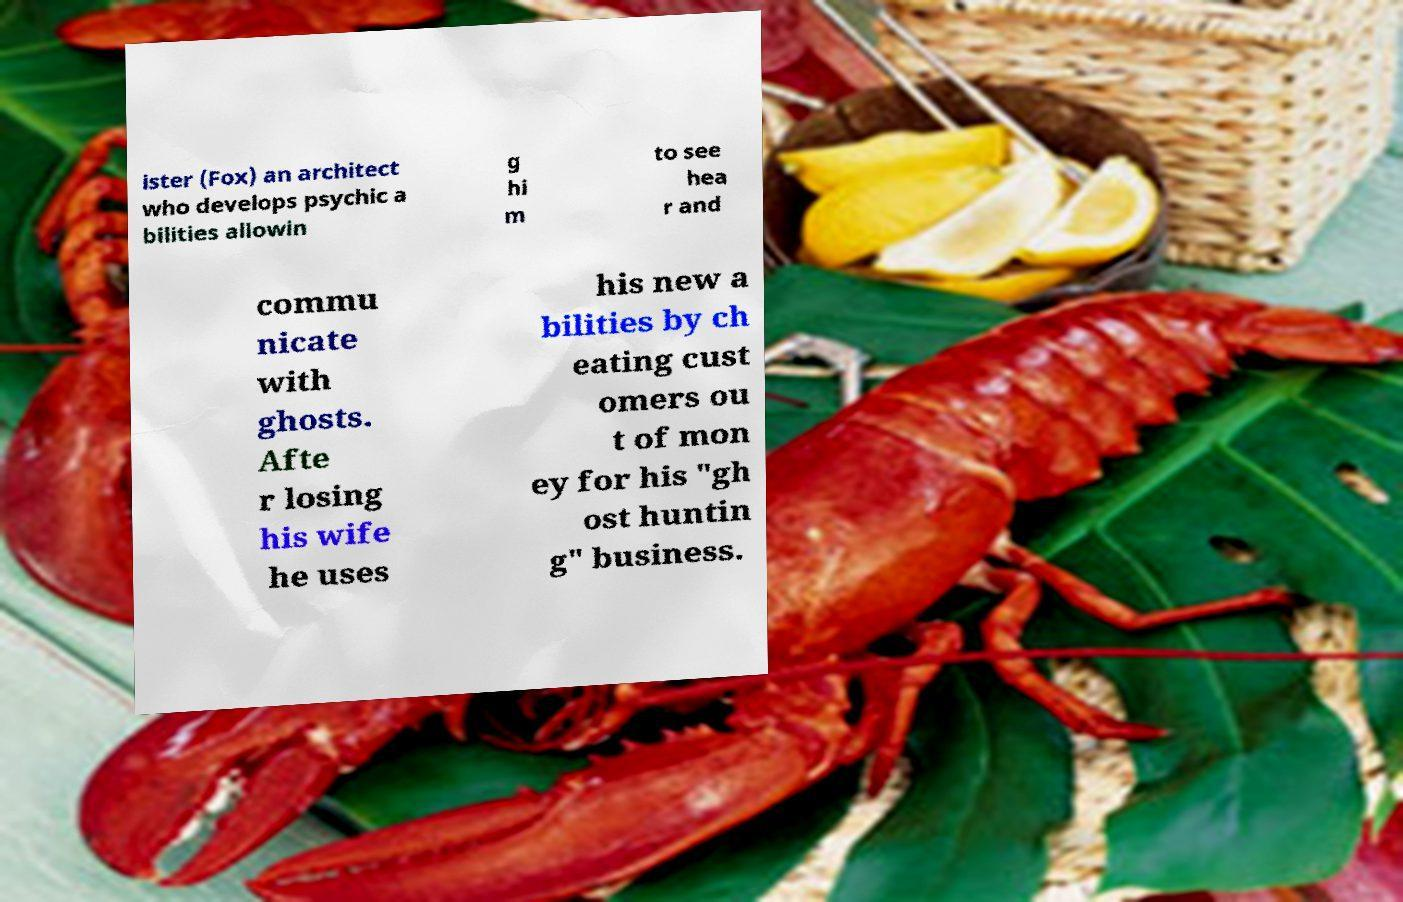Could you assist in decoding the text presented in this image and type it out clearly? ister (Fox) an architect who develops psychic a bilities allowin g hi m to see hea r and commu nicate with ghosts. Afte r losing his wife he uses his new a bilities by ch eating cust omers ou t of mon ey for his "gh ost huntin g" business. 